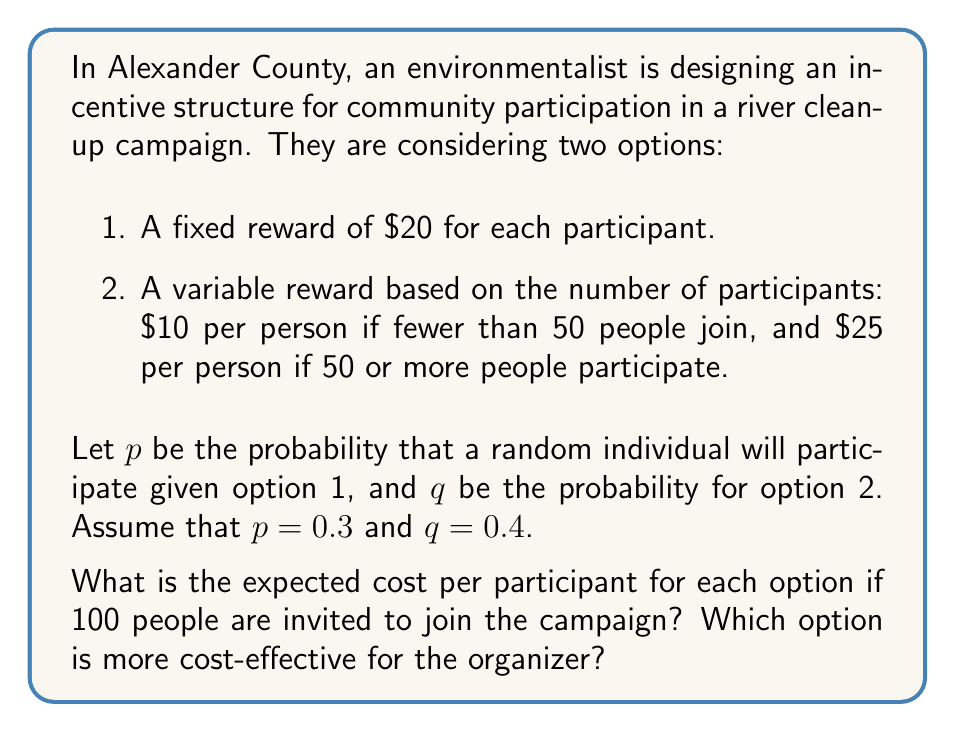Solve this math problem. Let's analyze each option separately:

Option 1: Fixed reward of $20

The expected number of participants is:
$$ E(\text{participants}) = 100 \cdot p = 100 \cdot 0.3 = 30 $$

The total cost for this option is:
$$ \text{Total Cost}_1 = 30 \cdot \$20 = \$600 $$

The expected cost per participant is:
$$ \text{Cost per Participant}_1 = \frac{\$600}{30} = \$20 $$

Option 2: Variable reward

For this option, we need to consider two scenarios:

Scenario A: Fewer than 50 people participate
Scenario B: 50 or more people participate

The probability of Scenario A occurring is:
$$ P(A) = \sum_{k=0}^{49} \binom{100}{k} q^k (1-q)^{100-k} $$

The probability of Scenario B occurring is:
$$ P(B) = 1 - P(A) $$

We can calculate these probabilities using the binomial distribution, but for simplicity, let's assume:
$$ P(A) = 0.3 \text{ and } P(B) = 0.7 $$

The expected number of participants is still:
$$ E(\text{participants}) = 100 \cdot q = 100 \cdot 0.4 = 40 $$

The expected total cost for this option is:
$$ \text{Total Cost}_2 = P(A) \cdot 40 \cdot \$10 + P(B) \cdot 40 \cdot \$25 $$
$$ \text{Total Cost}_2 = 0.3 \cdot 40 \cdot \$10 + 0.7 \cdot 40 \cdot \$25 = \$820 $$

The expected cost per participant is:
$$ \text{Cost per Participant}_2 = \frac{\$820}{40} = \$20.50 $$

Comparing the two options:
Option 1: $20 per participant
Option 2: $20.50 per participant

Therefore, Option 1 (fixed reward) is more cost-effective for the organizer.
Answer: Option 1 (fixed reward) is more cost-effective, with an expected cost of $20 per participant compared to $20.50 for Option 2. 